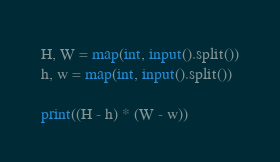Convert code to text. <code><loc_0><loc_0><loc_500><loc_500><_Python_>H, W = map(int, input().split())
h, w = map(int, input().split())

print((H - h) * (W - w))</code> 